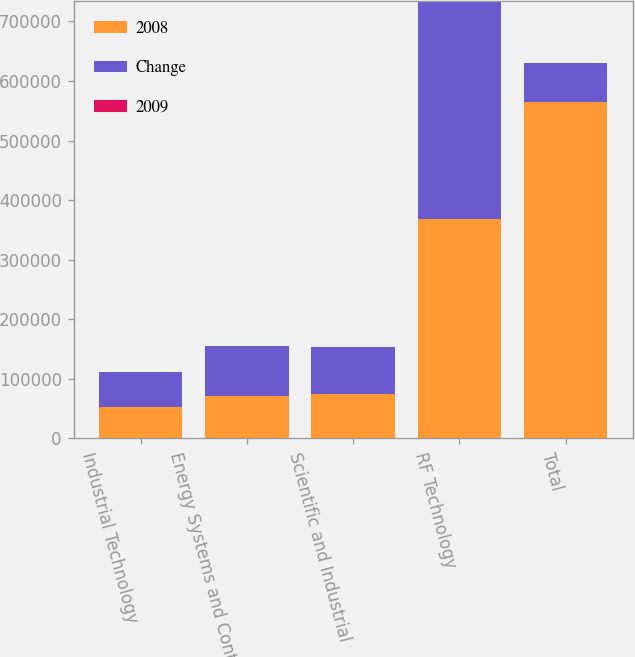Convert chart to OTSL. <chart><loc_0><loc_0><loc_500><loc_500><stacked_bar_chart><ecel><fcel>Industrial Technology<fcel>Energy Systems and Controls<fcel>Scientific and Industrial<fcel>RF Technology<fcel>Total<nl><fcel>2008<fcel>52079<fcel>70901<fcel>73747<fcel>368762<fcel>565489<nl><fcel>Change<fcel>59128<fcel>84997<fcel>80020<fcel>365669<fcel>65014.5<nl><fcel>2009<fcel>11.9<fcel>16.6<fcel>7.8<fcel>0.8<fcel>4.1<nl></chart> 